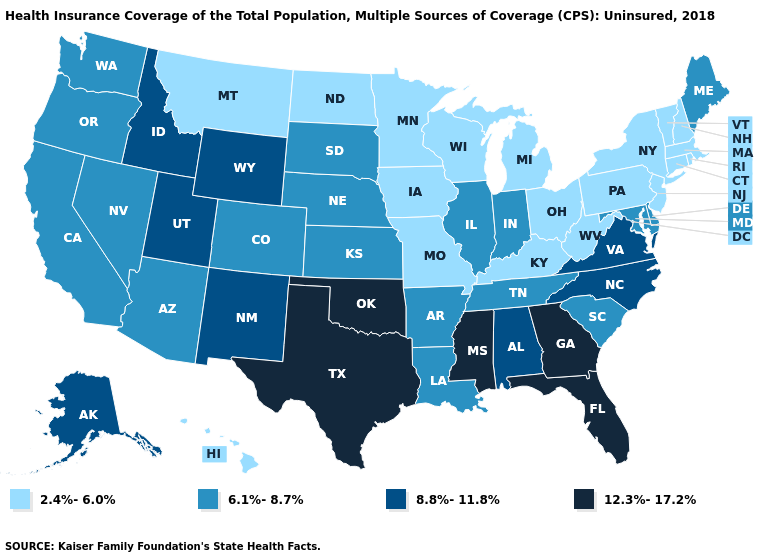What is the value of Alabama?
Give a very brief answer. 8.8%-11.8%. Name the states that have a value in the range 2.4%-6.0%?
Concise answer only. Connecticut, Hawaii, Iowa, Kentucky, Massachusetts, Michigan, Minnesota, Missouri, Montana, New Hampshire, New Jersey, New York, North Dakota, Ohio, Pennsylvania, Rhode Island, Vermont, West Virginia, Wisconsin. Among the states that border Michigan , does Indiana have the lowest value?
Give a very brief answer. No. Which states have the lowest value in the MidWest?
Give a very brief answer. Iowa, Michigan, Minnesota, Missouri, North Dakota, Ohio, Wisconsin. What is the highest value in the Northeast ?
Write a very short answer. 6.1%-8.7%. Does Mississippi have the lowest value in the USA?
Write a very short answer. No. Which states have the lowest value in the South?
Short answer required. Kentucky, West Virginia. What is the value of Maryland?
Concise answer only. 6.1%-8.7%. Name the states that have a value in the range 6.1%-8.7%?
Be succinct. Arizona, Arkansas, California, Colorado, Delaware, Illinois, Indiana, Kansas, Louisiana, Maine, Maryland, Nebraska, Nevada, Oregon, South Carolina, South Dakota, Tennessee, Washington. What is the value of Connecticut?
Quick response, please. 2.4%-6.0%. Among the states that border Missouri , which have the lowest value?
Be succinct. Iowa, Kentucky. What is the lowest value in the West?
Quick response, please. 2.4%-6.0%. Which states hav the highest value in the MidWest?
Short answer required. Illinois, Indiana, Kansas, Nebraska, South Dakota. Does Maine have the highest value in the Northeast?
Write a very short answer. Yes. What is the highest value in states that border Connecticut?
Write a very short answer. 2.4%-6.0%. 